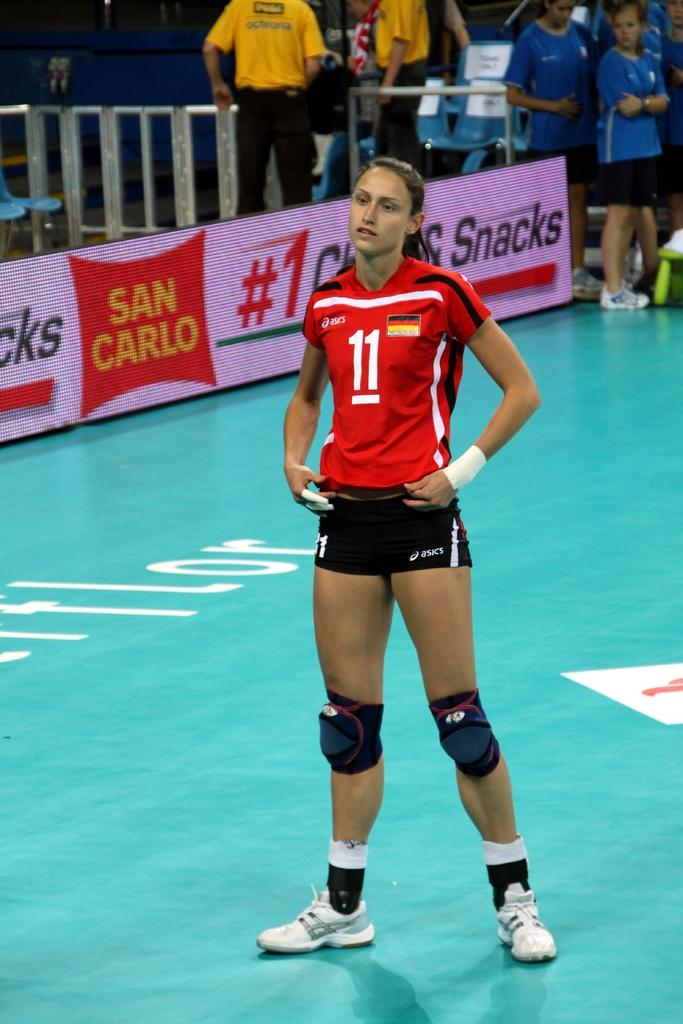<image>
Share a concise interpretation of the image provided. A girl in a uniform with the number 11 on it stands on a court with her hands at her hips. 